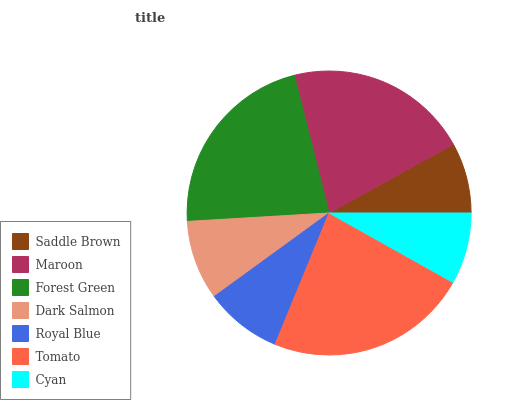Is Saddle Brown the minimum?
Answer yes or no. Yes. Is Tomato the maximum?
Answer yes or no. Yes. Is Maroon the minimum?
Answer yes or no. No. Is Maroon the maximum?
Answer yes or no. No. Is Maroon greater than Saddle Brown?
Answer yes or no. Yes. Is Saddle Brown less than Maroon?
Answer yes or no. Yes. Is Saddle Brown greater than Maroon?
Answer yes or no. No. Is Maroon less than Saddle Brown?
Answer yes or no. No. Is Dark Salmon the high median?
Answer yes or no. Yes. Is Dark Salmon the low median?
Answer yes or no. Yes. Is Tomato the high median?
Answer yes or no. No. Is Maroon the low median?
Answer yes or no. No. 